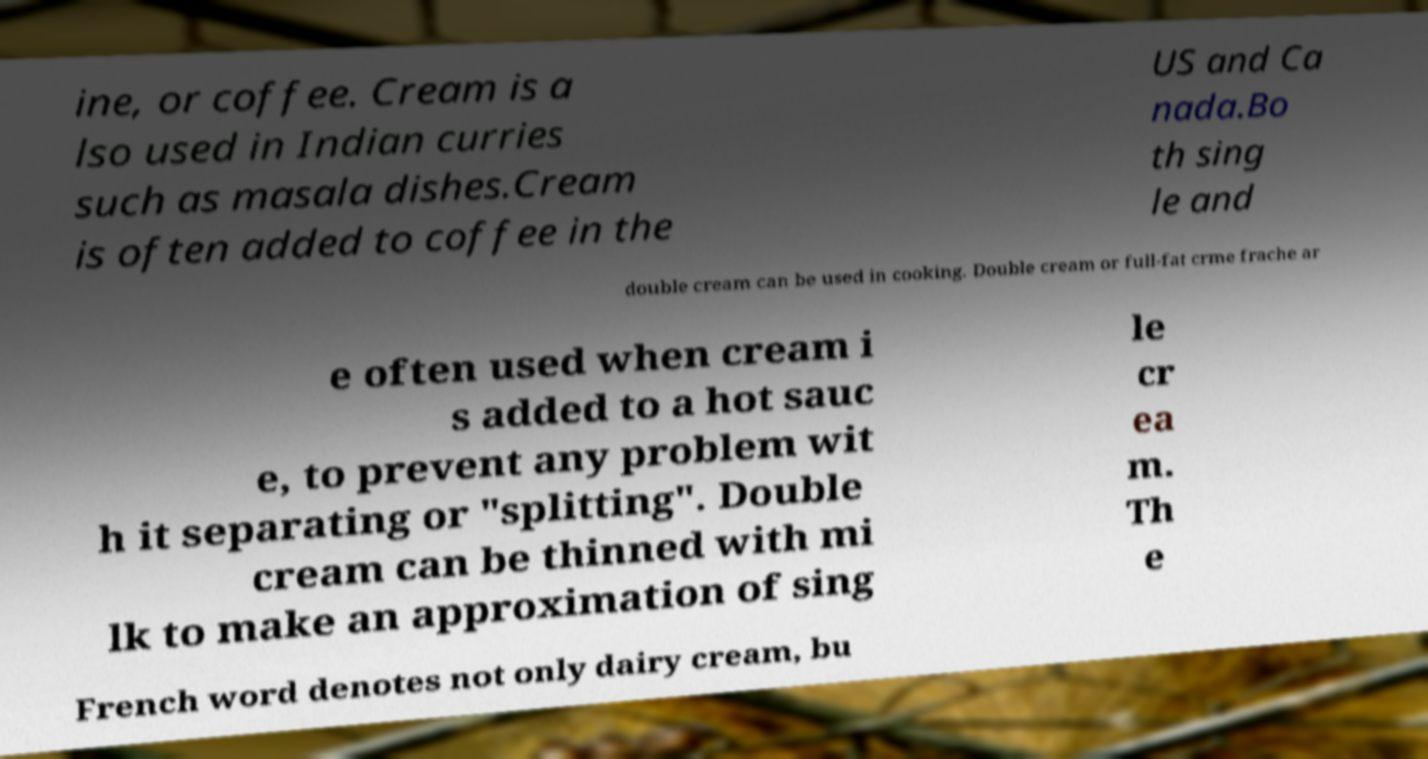Can you accurately transcribe the text from the provided image for me? ine, or coffee. Cream is a lso used in Indian curries such as masala dishes.Cream is often added to coffee in the US and Ca nada.Bo th sing le and double cream can be used in cooking. Double cream or full-fat crme frache ar e often used when cream i s added to a hot sauc e, to prevent any problem wit h it separating or "splitting". Double cream can be thinned with mi lk to make an approximation of sing le cr ea m. Th e French word denotes not only dairy cream, bu 